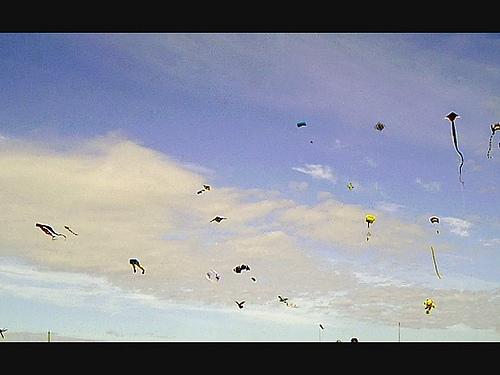What sport is being depicted in this image?
Keep it brief. Kite flying. Is it a cloudy day?
Keep it brief. Yes. Are any kite flyers successful?
Give a very brief answer. Yes. Can the flyers of the kites be seen?
Give a very brief answer. No. What else is in the sky,besides kites?
Quick response, please. Clouds. 